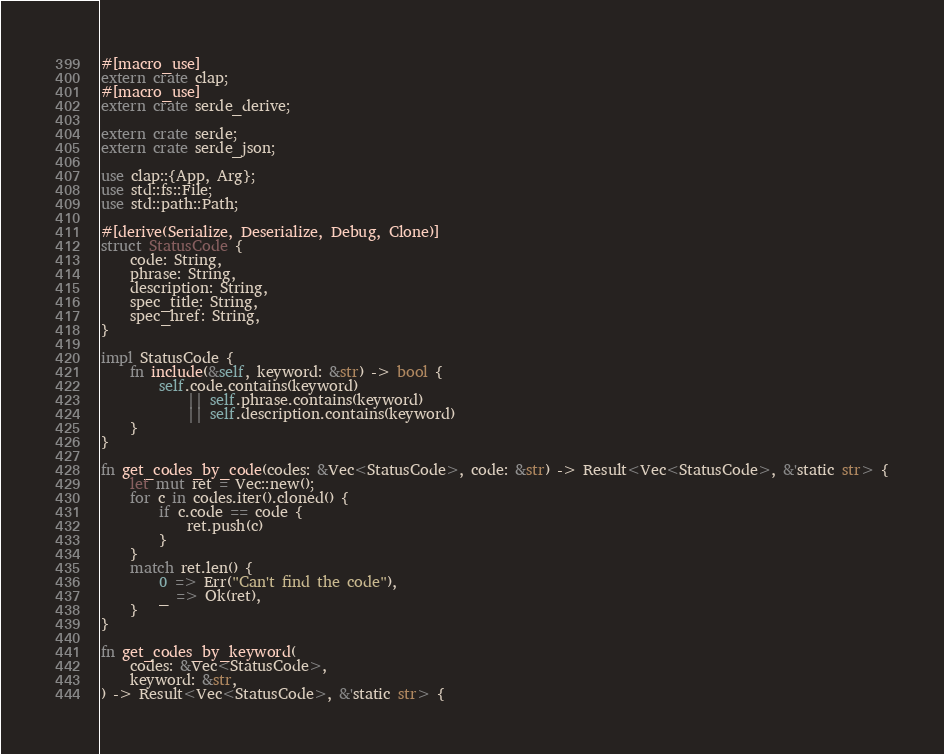<code> <loc_0><loc_0><loc_500><loc_500><_Rust_>#[macro_use]
extern crate clap;
#[macro_use]
extern crate serde_derive;

extern crate serde;
extern crate serde_json;

use clap::{App, Arg};
use std::fs::File;
use std::path::Path;

#[derive(Serialize, Deserialize, Debug, Clone)]
struct StatusCode {
    code: String,
    phrase: String,
    description: String,
    spec_title: String,
    spec_href: String,
}

impl StatusCode {
    fn include(&self, keyword: &str) -> bool {
        self.code.contains(keyword)
            || self.phrase.contains(keyword)
            || self.description.contains(keyword)
    }
}

fn get_codes_by_code(codes: &Vec<StatusCode>, code: &str) -> Result<Vec<StatusCode>, &'static str> {
    let mut ret = Vec::new();
    for c in codes.iter().cloned() {
        if c.code == code {
            ret.push(c)
        }
    }
    match ret.len() {
        0 => Err("Can't find the code"),
        _ => Ok(ret),
    }
}

fn get_codes_by_keyword(
    codes: &Vec<StatusCode>,
    keyword: &str,
) -> Result<Vec<StatusCode>, &'static str> {</code> 